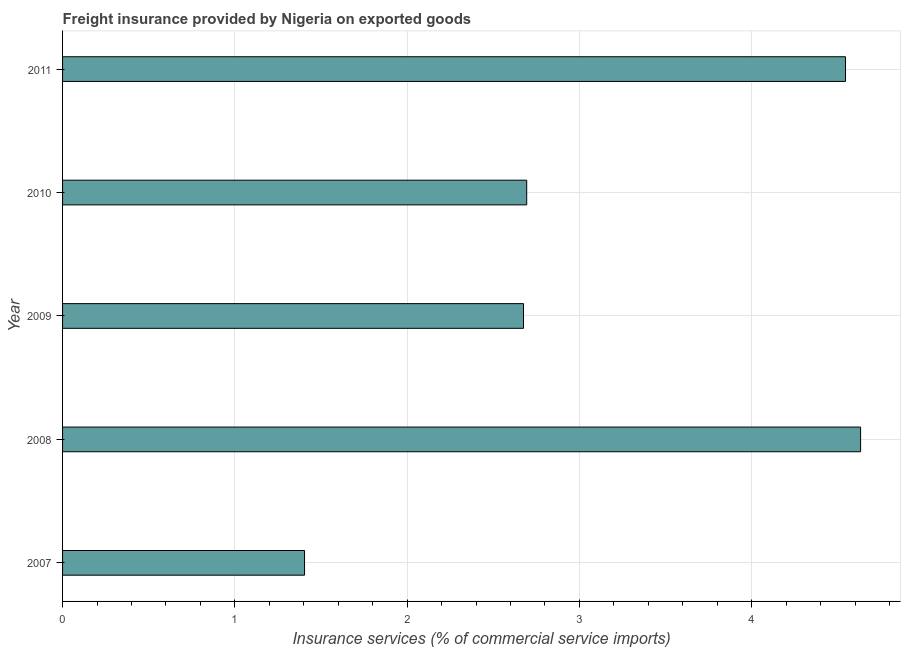What is the title of the graph?
Ensure brevity in your answer.  Freight insurance provided by Nigeria on exported goods . What is the label or title of the X-axis?
Offer a very short reply. Insurance services (% of commercial service imports). What is the label or title of the Y-axis?
Your answer should be compact. Year. What is the freight insurance in 2010?
Keep it short and to the point. 2.69. Across all years, what is the maximum freight insurance?
Offer a very short reply. 4.63. Across all years, what is the minimum freight insurance?
Make the answer very short. 1.4. In which year was the freight insurance minimum?
Ensure brevity in your answer.  2007. What is the sum of the freight insurance?
Make the answer very short. 15.95. What is the difference between the freight insurance in 2007 and 2011?
Offer a terse response. -3.14. What is the average freight insurance per year?
Your answer should be very brief. 3.19. What is the median freight insurance?
Provide a succinct answer. 2.69. Do a majority of the years between 2011 and 2007 (inclusive) have freight insurance greater than 4.4 %?
Provide a short and direct response. Yes. What is the ratio of the freight insurance in 2008 to that in 2010?
Your response must be concise. 1.72. Is the freight insurance in 2007 less than that in 2010?
Your response must be concise. Yes. Is the difference between the freight insurance in 2007 and 2010 greater than the difference between any two years?
Keep it short and to the point. No. What is the difference between the highest and the second highest freight insurance?
Ensure brevity in your answer.  0.09. What is the difference between the highest and the lowest freight insurance?
Provide a succinct answer. 3.23. In how many years, is the freight insurance greater than the average freight insurance taken over all years?
Your answer should be compact. 2. How many bars are there?
Keep it short and to the point. 5. Are all the bars in the graph horizontal?
Your answer should be compact. Yes. How many years are there in the graph?
Make the answer very short. 5. What is the Insurance services (% of commercial service imports) in 2007?
Make the answer very short. 1.4. What is the Insurance services (% of commercial service imports) in 2008?
Keep it short and to the point. 4.63. What is the Insurance services (% of commercial service imports) of 2009?
Offer a terse response. 2.68. What is the Insurance services (% of commercial service imports) in 2010?
Your answer should be very brief. 2.69. What is the Insurance services (% of commercial service imports) in 2011?
Your answer should be compact. 4.54. What is the difference between the Insurance services (% of commercial service imports) in 2007 and 2008?
Offer a very short reply. -3.23. What is the difference between the Insurance services (% of commercial service imports) in 2007 and 2009?
Your answer should be very brief. -1.27. What is the difference between the Insurance services (% of commercial service imports) in 2007 and 2010?
Your answer should be very brief. -1.29. What is the difference between the Insurance services (% of commercial service imports) in 2007 and 2011?
Offer a very short reply. -3.14. What is the difference between the Insurance services (% of commercial service imports) in 2008 and 2009?
Your answer should be very brief. 1.96. What is the difference between the Insurance services (% of commercial service imports) in 2008 and 2010?
Your answer should be very brief. 1.94. What is the difference between the Insurance services (% of commercial service imports) in 2008 and 2011?
Provide a short and direct response. 0.09. What is the difference between the Insurance services (% of commercial service imports) in 2009 and 2010?
Your response must be concise. -0.02. What is the difference between the Insurance services (% of commercial service imports) in 2009 and 2011?
Offer a terse response. -1.87. What is the difference between the Insurance services (% of commercial service imports) in 2010 and 2011?
Offer a terse response. -1.85. What is the ratio of the Insurance services (% of commercial service imports) in 2007 to that in 2008?
Keep it short and to the point. 0.3. What is the ratio of the Insurance services (% of commercial service imports) in 2007 to that in 2009?
Give a very brief answer. 0.53. What is the ratio of the Insurance services (% of commercial service imports) in 2007 to that in 2010?
Your response must be concise. 0.52. What is the ratio of the Insurance services (% of commercial service imports) in 2007 to that in 2011?
Provide a short and direct response. 0.31. What is the ratio of the Insurance services (% of commercial service imports) in 2008 to that in 2009?
Offer a terse response. 1.73. What is the ratio of the Insurance services (% of commercial service imports) in 2008 to that in 2010?
Offer a very short reply. 1.72. What is the ratio of the Insurance services (% of commercial service imports) in 2009 to that in 2011?
Provide a short and direct response. 0.59. What is the ratio of the Insurance services (% of commercial service imports) in 2010 to that in 2011?
Your answer should be very brief. 0.59. 